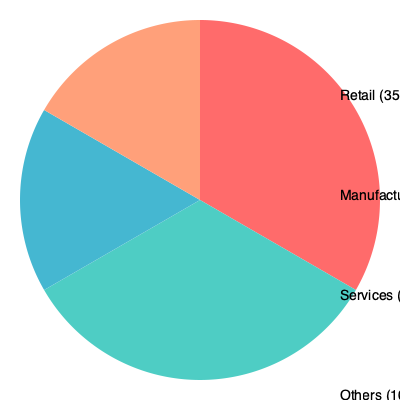Based on the pie chart showing the distribution of tax deductions claimed by various types of businesses, what is the ratio of tax deductions claimed by the manufacturing sector to the services sector? To find the ratio of tax deductions claimed by the manufacturing sector to the services sector, we need to follow these steps:

1. Identify the percentages for manufacturing and services sectors:
   - Manufacturing: 30%
   - Services: 25%

2. Express the ratio as a fraction:
   $\frac{\text{Manufacturing}}{\text{Services}} = \frac{30}{25}$

3. Simplify the fraction:
   $\frac{30}{25} = \frac{6}{5} = 1.2$

Therefore, the ratio of tax deductions claimed by the manufacturing sector to the services sector is $6:5$ or $1.2:1$.
Answer: $6:5$ or $1.2:1$ 